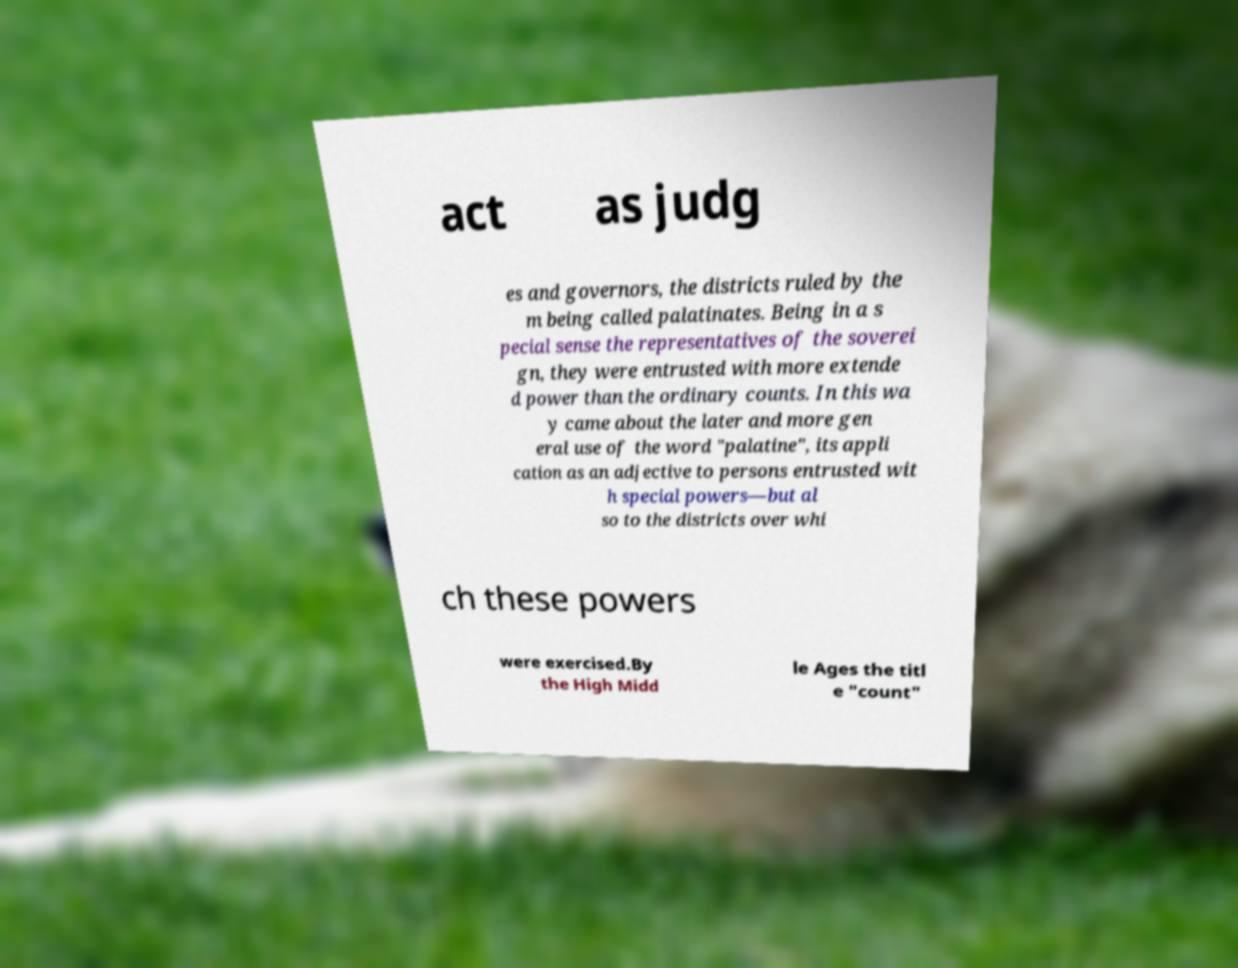Could you assist in decoding the text presented in this image and type it out clearly? act as judg es and governors, the districts ruled by the m being called palatinates. Being in a s pecial sense the representatives of the soverei gn, they were entrusted with more extende d power than the ordinary counts. In this wa y came about the later and more gen eral use of the word "palatine", its appli cation as an adjective to persons entrusted wit h special powers—but al so to the districts over whi ch these powers were exercised.By the High Midd le Ages the titl e "count" 